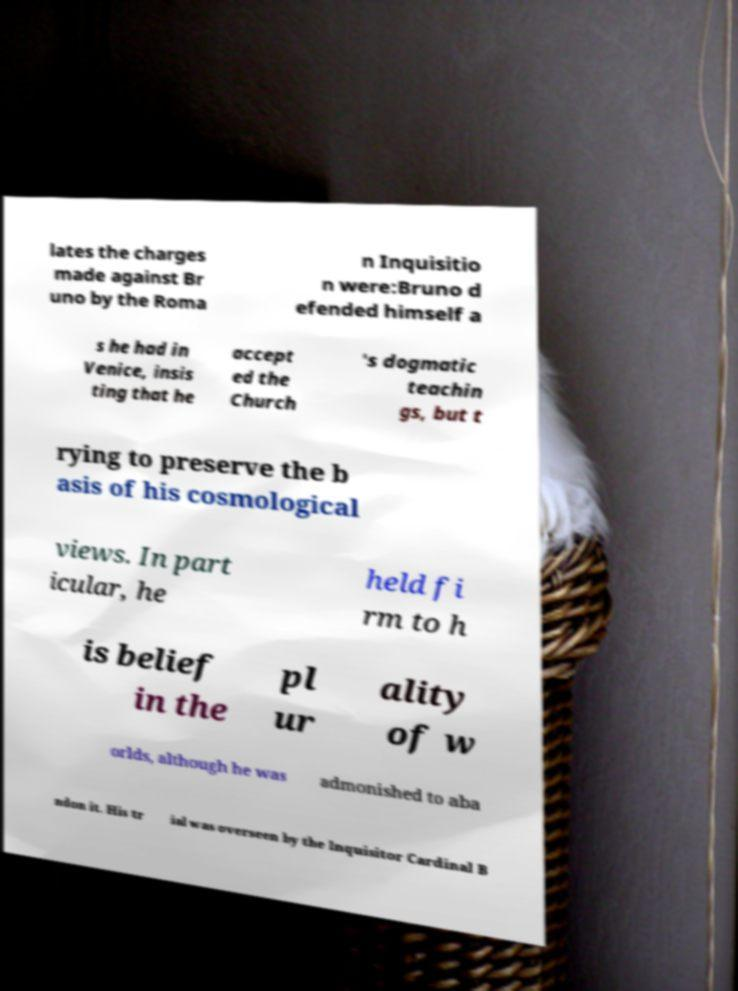Could you assist in decoding the text presented in this image and type it out clearly? lates the charges made against Br uno by the Roma n Inquisitio n were:Bruno d efended himself a s he had in Venice, insis ting that he accept ed the Church 's dogmatic teachin gs, but t rying to preserve the b asis of his cosmological views. In part icular, he held fi rm to h is belief in the pl ur ality of w orlds, although he was admonished to aba ndon it. His tr ial was overseen by the Inquisitor Cardinal B 